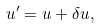<formula> <loc_0><loc_0><loc_500><loc_500>u ^ { \prime } = u + \delta u ,</formula> 